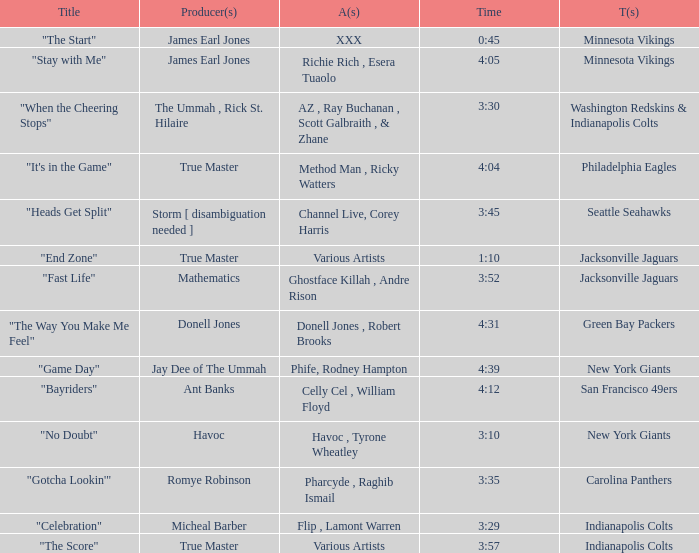Who is the artist of the Seattle Seahawks track? Channel Live, Corey Harris. 